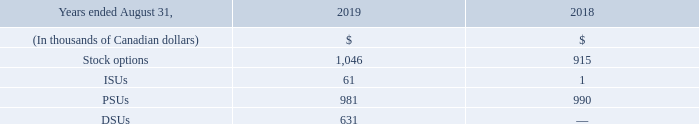Cogeco Communications is a subsidiary of Cogeco, which holds 31.8% of the Corporation's equity shares, representing 82.3% of the Corporation's voting shares.
Cogeco provides executive, administrative, financial and strategic planning services and additional services to the Corporation under a Management Services Agreement (the "Agreement"). On May 1, 2019, the Corporation and Cogeco agreed to amend the Agreement in order to replace the methodology used to establish the management fees payable by the Corporation to Cogeco, which was based on a percentage of the consolidated revenue of the Corporation, with a new methodology based on the costs incurred by Cogeco plus a reasonable mark-up. This cost-plus methodology was adopted to avoid future variations of the management fee percentage due to the frequent changes of the Corporation's consolidated revenue pursuant to business acquisitions and divestitures. Prior to this change, management fees represented 0.75% of the consolidated revenue from continuing and discontinued operations of the Corporation (0.85% for the period prior to the MetroCast acquisition on January 4, 2018). Provision is made for future adjustment upon the request of either Cogeco or the Corporation from time to time during the term of the Agreement. For fiscal 2019 management fees paid to Cogeco amounted to $19.9 million, compared to $19.0 million for fiscal 2018.
Provision is made for future adjustment upon the request of either Cogeco or the Corporation from time to time during the term of the Agreement. For fiscal 2019 management fees paid to Cogeco amounted to $19.9 million, compared to $19.0 million for fiscal 2018.
The following table shows the amounts that the Corporation charged Cogeco with regards to the Corporation's stock options, ISUs and PSUs granted to these executive officers, as well as DSUs issued to Board directors of Cogeco:
What is the ownership of Cogeco in Cogeco Communications in terms of voting shares? 82.3%. What was the management fee prior to the methodology change? 0.75% of the consolidated revenue from continuing and discontinued operations of the corporation (0.85% for the period prior to the metrocast acquisition on january 4, 2018). What was the management fee paid to Cogeco in 2019? $19.9 million. What is the increase / (decrease) in the stock options from 2018 to 2019?
Answer scale should be: thousand. 1,046 - 915
Answer: 131. What was the average ISUs from 2018 to 2019?
Answer scale should be: thousand. (61 + 1) / 2
Answer: 31. What was the average DSUs from 2018 to 2019?
Answer scale should be: thousand. (631 + 0) / 2
Answer: 315.5. 